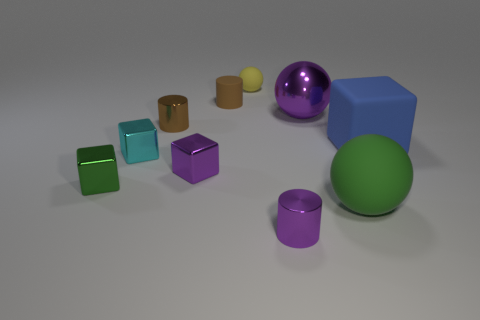Subtract all gray cubes. Subtract all brown cylinders. How many cubes are left? 4 Subtract all spheres. How many objects are left? 7 Subtract all small green shiny cubes. Subtract all small purple metal blocks. How many objects are left? 8 Add 7 small cyan metal objects. How many small cyan metal objects are left? 8 Add 2 small green cubes. How many small green cubes exist? 3 Subtract 0 gray cylinders. How many objects are left? 10 